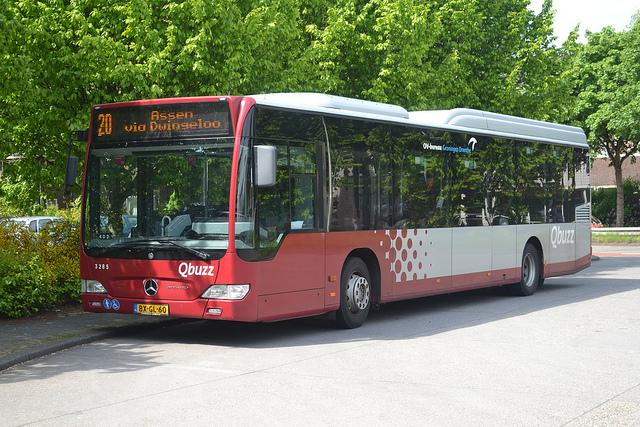What group of people are accommodated in this bus? tourists 